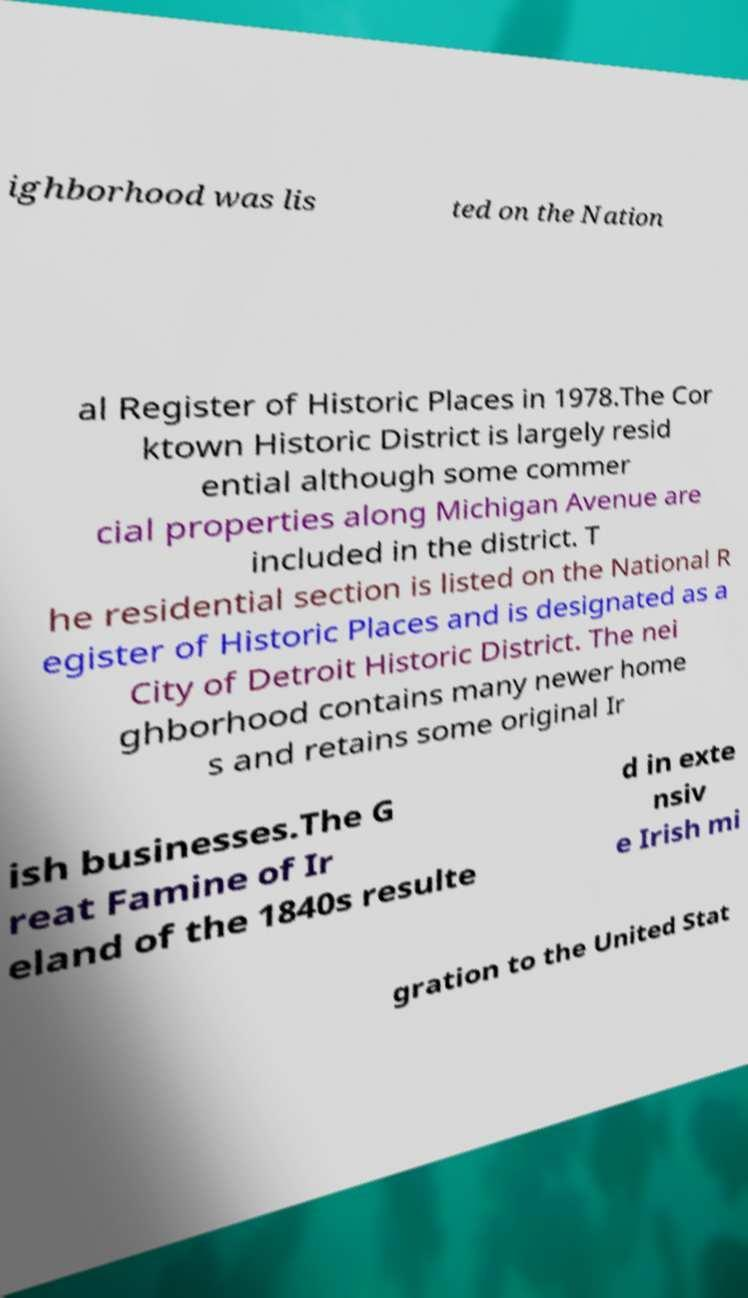Can you read and provide the text displayed in the image?This photo seems to have some interesting text. Can you extract and type it out for me? ighborhood was lis ted on the Nation al Register of Historic Places in 1978.The Cor ktown Historic District is largely resid ential although some commer cial properties along Michigan Avenue are included in the district. T he residential section is listed on the National R egister of Historic Places and is designated as a City of Detroit Historic District. The nei ghborhood contains many newer home s and retains some original Ir ish businesses.The G reat Famine of Ir eland of the 1840s resulte d in exte nsiv e Irish mi gration to the United Stat 